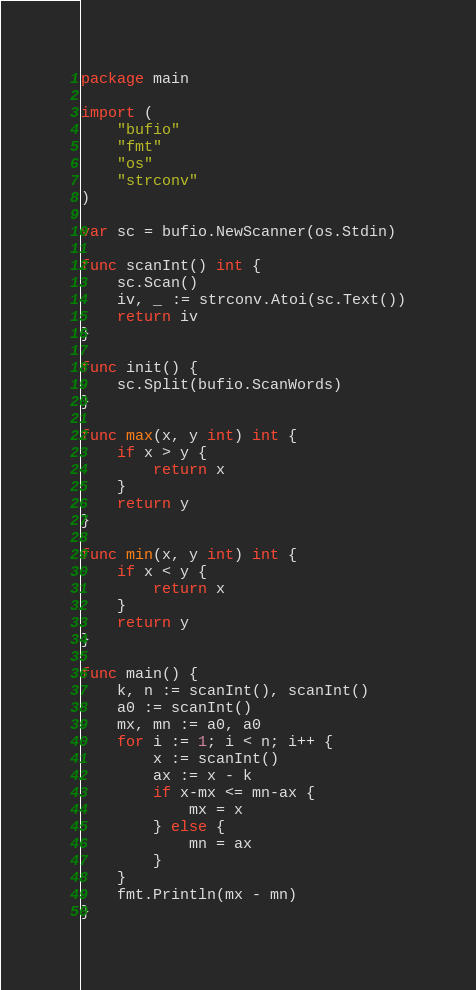<code> <loc_0><loc_0><loc_500><loc_500><_Go_>package main

import (
	"bufio"
	"fmt"
	"os"
	"strconv"
)

var sc = bufio.NewScanner(os.Stdin)

func scanInt() int {
	sc.Scan()
	iv, _ := strconv.Atoi(sc.Text())
	return iv
}

func init() {
	sc.Split(bufio.ScanWords)
}

func max(x, y int) int {
	if x > y {
		return x
	}
	return y
}

func min(x, y int) int {
	if x < y {
		return x
	}
	return y
}

func main() {
	k, n := scanInt(), scanInt()
	a0 := scanInt()
	mx, mn := a0, a0
	for i := 1; i < n; i++ {
		x := scanInt()
		ax := x - k
		if x-mx <= mn-ax {
			mx = x
		} else {
			mn = ax
		}
	}
	fmt.Println(mx - mn)
}
</code> 